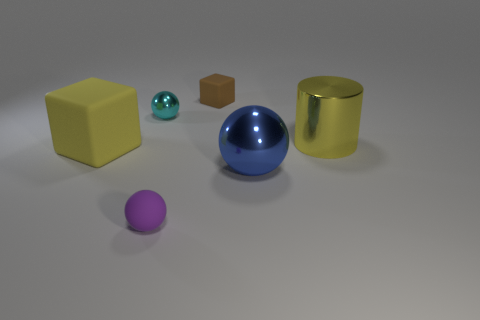There is a big cylinder that is the same color as the big matte thing; what is its material?
Make the answer very short. Metal. What size is the object that is both right of the yellow cube and on the left side of the small purple object?
Your answer should be very brief. Small. What number of cylinders are blue metallic things or cyan things?
Give a very brief answer. 0. There is a block that is the same size as the blue metal ball; what is its color?
Keep it short and to the point. Yellow. Is there anything else that has the same shape as the small purple thing?
Keep it short and to the point. Yes. What color is the other tiny thing that is the same shape as the tiny purple object?
Provide a succinct answer. Cyan. How many things are brown things or tiny matte things in front of the tiny cyan shiny thing?
Offer a terse response. 2. Are there fewer tiny brown cubes behind the purple thing than small red metallic cylinders?
Your answer should be compact. No. There is a thing that is to the right of the shiny sphere on the right side of the small matte thing left of the small block; what size is it?
Give a very brief answer. Large. The object that is both to the right of the brown matte object and left of the large cylinder is what color?
Give a very brief answer. Blue. 